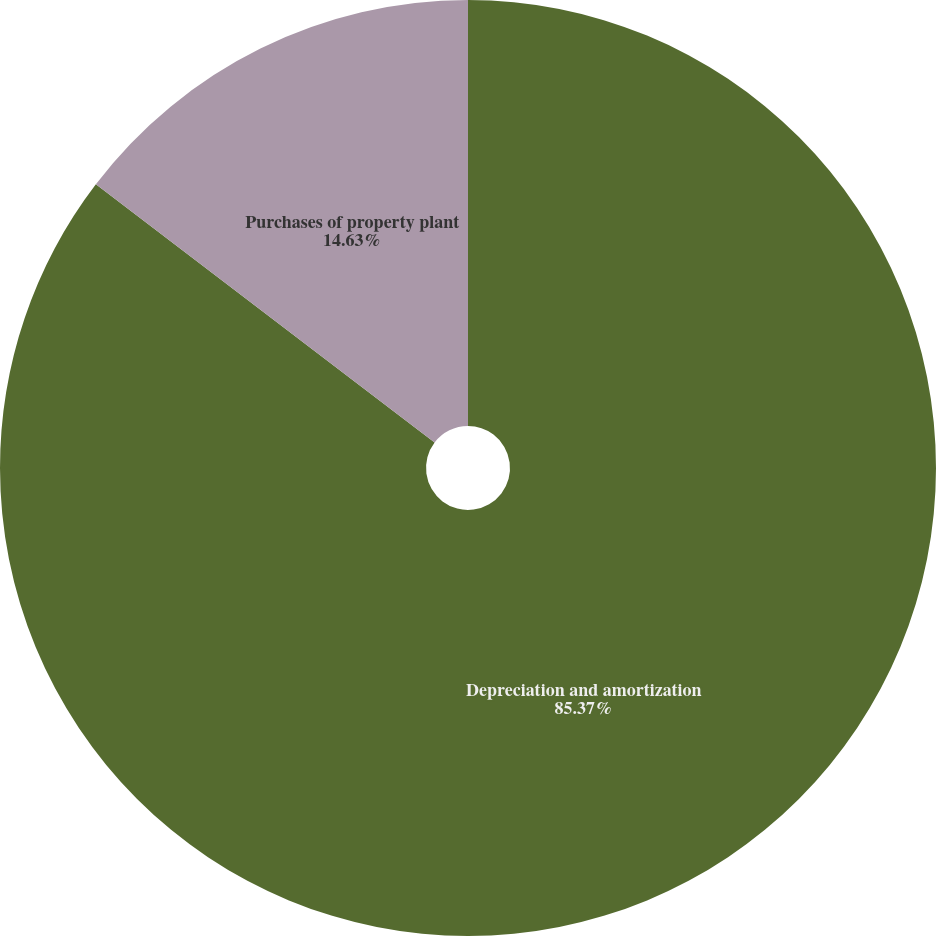<chart> <loc_0><loc_0><loc_500><loc_500><pie_chart><fcel>Depreciation and amortization<fcel>Purchases of property plant<nl><fcel>85.37%<fcel>14.63%<nl></chart> 